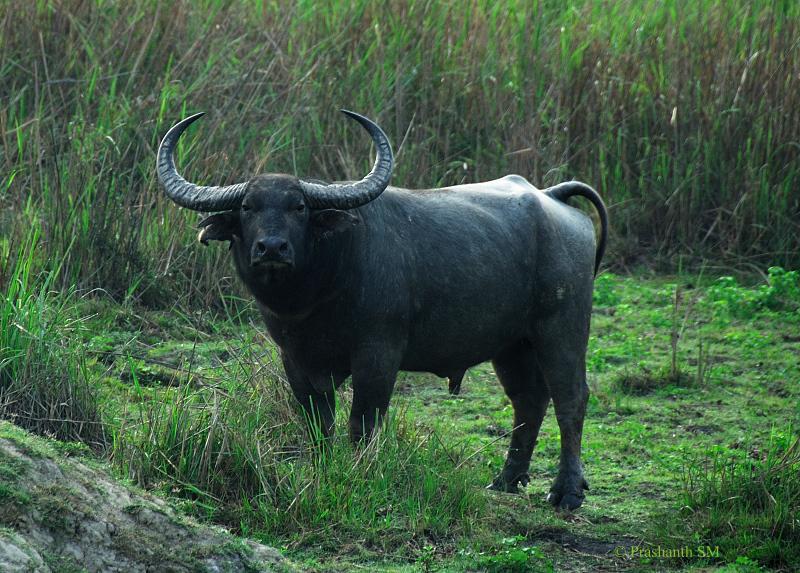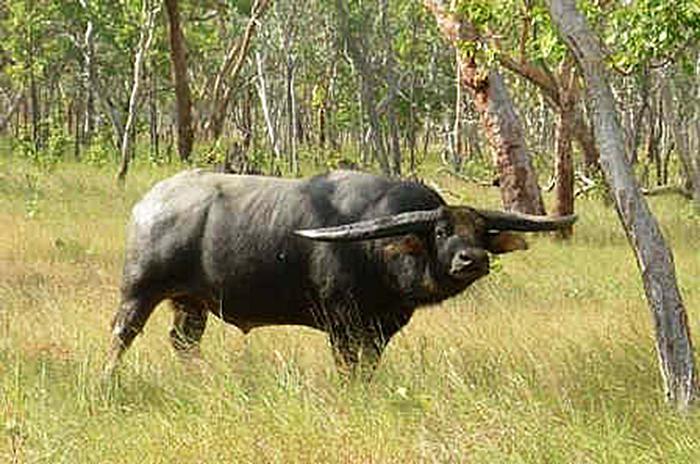The first image is the image on the left, the second image is the image on the right. Evaluate the accuracy of this statement regarding the images: "The tail on the cow on the right is seen behind it.". Is it true? Answer yes or no. No. The first image is the image on the left, the second image is the image on the right. Considering the images on both sides, is "There are two buffalos facing away from each other." valid? Answer yes or no. Yes. 